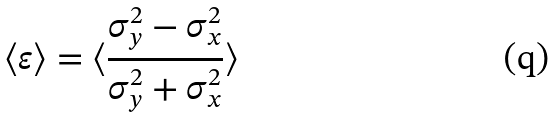<formula> <loc_0><loc_0><loc_500><loc_500>\langle \varepsilon \rangle = \langle \frac { \sigma ^ { 2 } _ { y } - \sigma ^ { 2 } _ { x } } { \sigma ^ { 2 } _ { y } + \sigma ^ { 2 } _ { x } } \rangle</formula> 